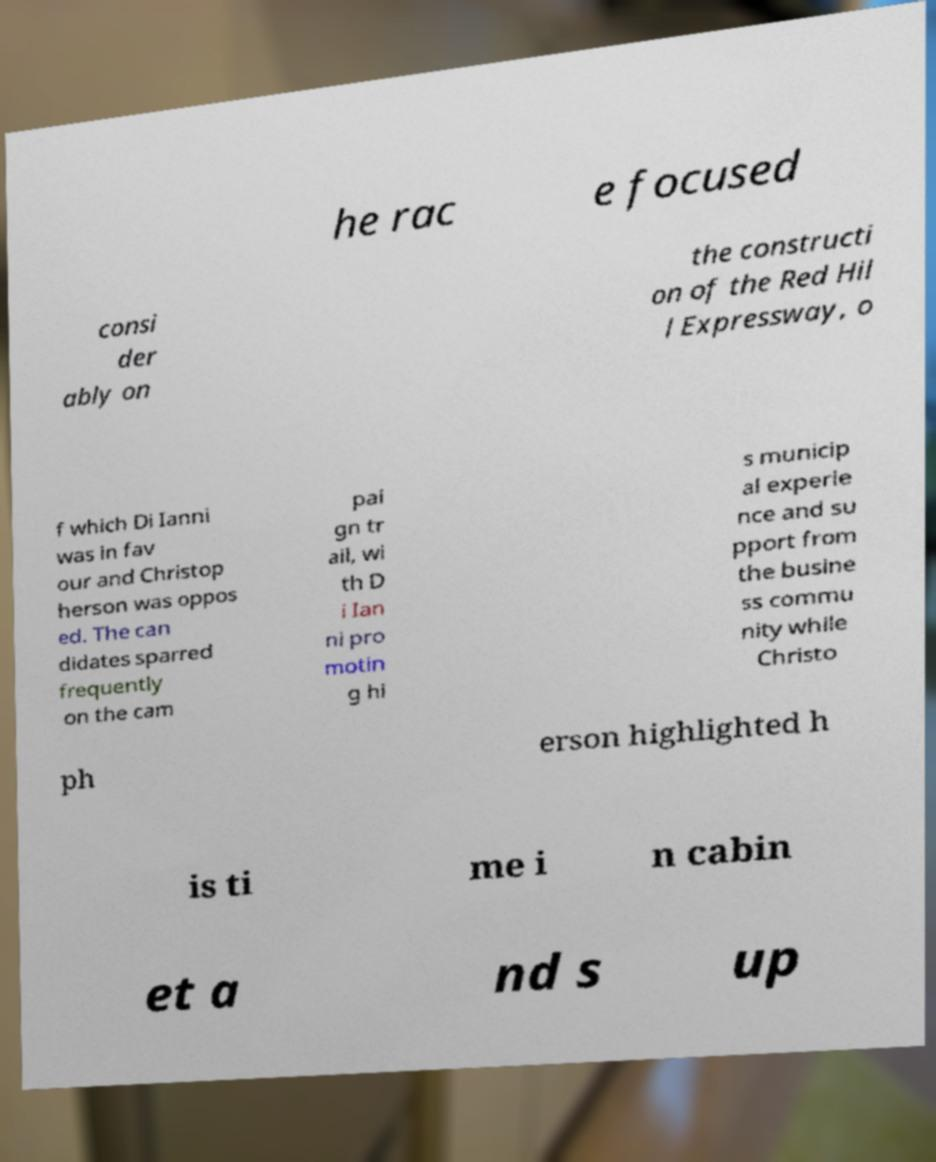What messages or text are displayed in this image? I need them in a readable, typed format. he rac e focused consi der ably on the constructi on of the Red Hil l Expressway, o f which Di Ianni was in fav our and Christop herson was oppos ed. The can didates sparred frequently on the cam pai gn tr ail, wi th D i Ian ni pro motin g hi s municip al experie nce and su pport from the busine ss commu nity while Christo ph erson highlighted h is ti me i n cabin et a nd s up 